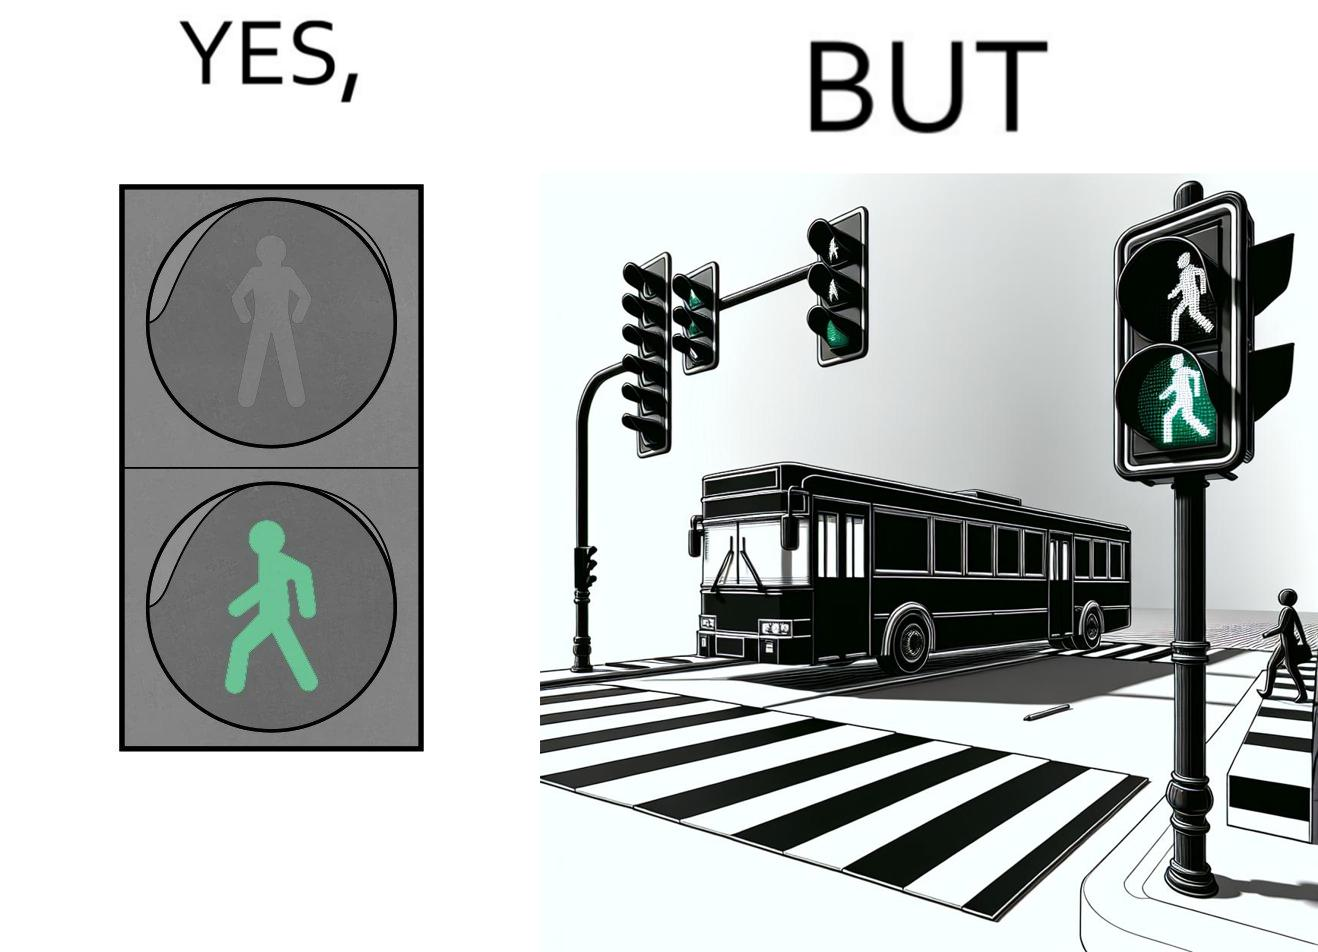What is shown in this image? The image is ironic, because even when the signal is green for the pedestrians but they can't cross the road because of the vehicles standing on the zebra crossing 